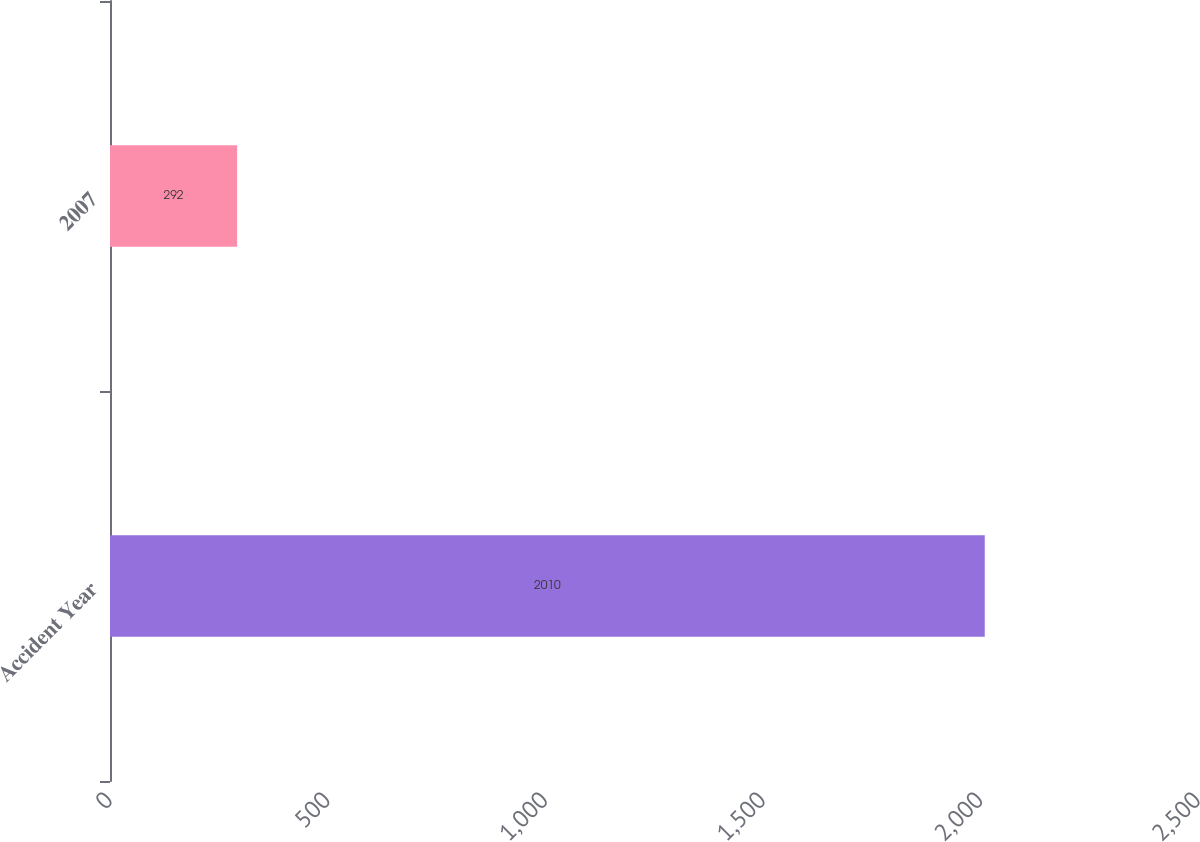Convert chart to OTSL. <chart><loc_0><loc_0><loc_500><loc_500><bar_chart><fcel>Accident Year<fcel>2007<nl><fcel>2010<fcel>292<nl></chart> 